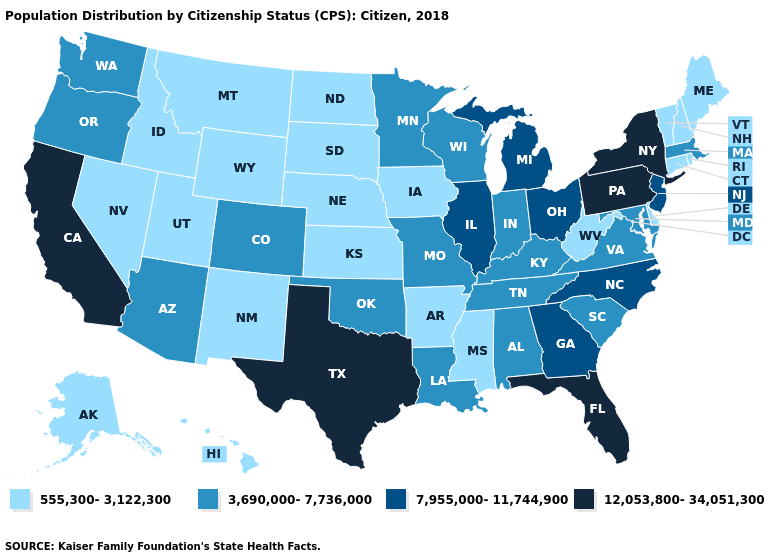What is the highest value in states that border Florida?
Write a very short answer. 7,955,000-11,744,900. What is the value of Hawaii?
Short answer required. 555,300-3,122,300. Does Nebraska have the lowest value in the MidWest?
Give a very brief answer. Yes. What is the highest value in the South ?
Quick response, please. 12,053,800-34,051,300. Does the first symbol in the legend represent the smallest category?
Concise answer only. Yes. Name the states that have a value in the range 12,053,800-34,051,300?
Quick response, please. California, Florida, New York, Pennsylvania, Texas. Name the states that have a value in the range 12,053,800-34,051,300?
Keep it brief. California, Florida, New York, Pennsylvania, Texas. What is the highest value in the South ?
Give a very brief answer. 12,053,800-34,051,300. Name the states that have a value in the range 555,300-3,122,300?
Be succinct. Alaska, Arkansas, Connecticut, Delaware, Hawaii, Idaho, Iowa, Kansas, Maine, Mississippi, Montana, Nebraska, Nevada, New Hampshire, New Mexico, North Dakota, Rhode Island, South Dakota, Utah, Vermont, West Virginia, Wyoming. Is the legend a continuous bar?
Give a very brief answer. No. What is the value of South Carolina?
Give a very brief answer. 3,690,000-7,736,000. Does Maine have the highest value in the Northeast?
Keep it brief. No. What is the value of Kansas?
Be succinct. 555,300-3,122,300. What is the value of Iowa?
Write a very short answer. 555,300-3,122,300. What is the value of Rhode Island?
Answer briefly. 555,300-3,122,300. 